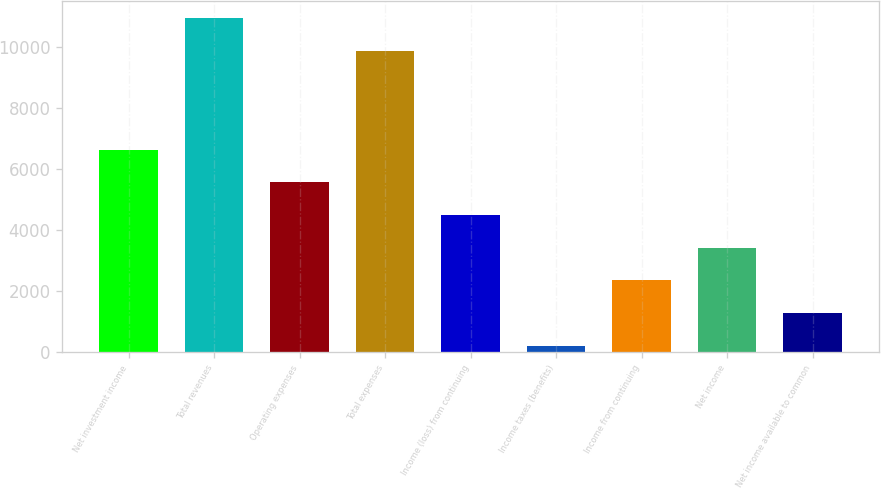<chart> <loc_0><loc_0><loc_500><loc_500><bar_chart><fcel>Net investment income<fcel>Total revenues<fcel>Operating expenses<fcel>Total expenses<fcel>Income (loss) from continuing<fcel>Income taxes (benefits)<fcel>Income from continuing<fcel>Net income<fcel>Net income available to common<nl><fcel>6627.14<fcel>10928.1<fcel>5557.3<fcel>9858.3<fcel>4487.46<fcel>208.1<fcel>2347.78<fcel>3417.62<fcel>1277.94<nl></chart> 